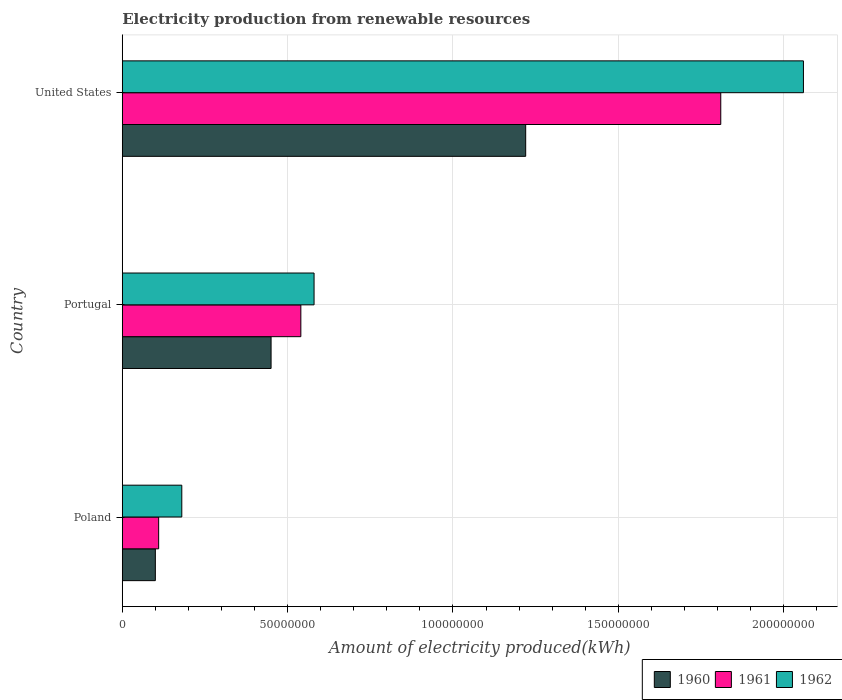How many different coloured bars are there?
Ensure brevity in your answer.  3. How many groups of bars are there?
Your response must be concise. 3. Are the number of bars on each tick of the Y-axis equal?
Offer a very short reply. Yes. How many bars are there on the 2nd tick from the bottom?
Keep it short and to the point. 3. What is the label of the 3rd group of bars from the top?
Your answer should be very brief. Poland. In how many cases, is the number of bars for a given country not equal to the number of legend labels?
Your response must be concise. 0. What is the amount of electricity produced in 1962 in Portugal?
Your answer should be very brief. 5.80e+07. Across all countries, what is the maximum amount of electricity produced in 1960?
Give a very brief answer. 1.22e+08. Across all countries, what is the minimum amount of electricity produced in 1961?
Ensure brevity in your answer.  1.10e+07. In which country was the amount of electricity produced in 1961 maximum?
Your answer should be compact. United States. In which country was the amount of electricity produced in 1961 minimum?
Your answer should be very brief. Poland. What is the total amount of electricity produced in 1962 in the graph?
Offer a terse response. 2.82e+08. What is the difference between the amount of electricity produced in 1961 in Poland and that in Portugal?
Give a very brief answer. -4.30e+07. What is the difference between the amount of electricity produced in 1962 in Poland and the amount of electricity produced in 1961 in United States?
Offer a terse response. -1.63e+08. What is the average amount of electricity produced in 1960 per country?
Your answer should be very brief. 5.90e+07. What is the difference between the amount of electricity produced in 1961 and amount of electricity produced in 1962 in United States?
Your answer should be compact. -2.50e+07. What is the ratio of the amount of electricity produced in 1960 in Poland to that in United States?
Provide a short and direct response. 0.08. Is the difference between the amount of electricity produced in 1961 in Portugal and United States greater than the difference between the amount of electricity produced in 1962 in Portugal and United States?
Keep it short and to the point. Yes. What is the difference between the highest and the second highest amount of electricity produced in 1962?
Offer a very short reply. 1.48e+08. What is the difference between the highest and the lowest amount of electricity produced in 1960?
Your answer should be compact. 1.12e+08. Is the sum of the amount of electricity produced in 1962 in Poland and Portugal greater than the maximum amount of electricity produced in 1961 across all countries?
Keep it short and to the point. No. What does the 3rd bar from the bottom in Poland represents?
Provide a short and direct response. 1962. How many bars are there?
Your answer should be very brief. 9. Are all the bars in the graph horizontal?
Ensure brevity in your answer.  Yes. How many countries are there in the graph?
Offer a terse response. 3. What is the difference between two consecutive major ticks on the X-axis?
Ensure brevity in your answer.  5.00e+07. Where does the legend appear in the graph?
Make the answer very short. Bottom right. What is the title of the graph?
Your answer should be compact. Electricity production from renewable resources. Does "1975" appear as one of the legend labels in the graph?
Provide a succinct answer. No. What is the label or title of the X-axis?
Your response must be concise. Amount of electricity produced(kWh). What is the Amount of electricity produced(kWh) in 1961 in Poland?
Make the answer very short. 1.10e+07. What is the Amount of electricity produced(kWh) in 1962 in Poland?
Provide a succinct answer. 1.80e+07. What is the Amount of electricity produced(kWh) in 1960 in Portugal?
Your answer should be very brief. 4.50e+07. What is the Amount of electricity produced(kWh) of 1961 in Portugal?
Offer a terse response. 5.40e+07. What is the Amount of electricity produced(kWh) in 1962 in Portugal?
Make the answer very short. 5.80e+07. What is the Amount of electricity produced(kWh) of 1960 in United States?
Offer a terse response. 1.22e+08. What is the Amount of electricity produced(kWh) in 1961 in United States?
Give a very brief answer. 1.81e+08. What is the Amount of electricity produced(kWh) of 1962 in United States?
Ensure brevity in your answer.  2.06e+08. Across all countries, what is the maximum Amount of electricity produced(kWh) of 1960?
Provide a succinct answer. 1.22e+08. Across all countries, what is the maximum Amount of electricity produced(kWh) in 1961?
Offer a terse response. 1.81e+08. Across all countries, what is the maximum Amount of electricity produced(kWh) of 1962?
Your answer should be compact. 2.06e+08. Across all countries, what is the minimum Amount of electricity produced(kWh) of 1960?
Give a very brief answer. 1.00e+07. Across all countries, what is the minimum Amount of electricity produced(kWh) of 1961?
Your answer should be very brief. 1.10e+07. Across all countries, what is the minimum Amount of electricity produced(kWh) of 1962?
Your response must be concise. 1.80e+07. What is the total Amount of electricity produced(kWh) of 1960 in the graph?
Give a very brief answer. 1.77e+08. What is the total Amount of electricity produced(kWh) of 1961 in the graph?
Make the answer very short. 2.46e+08. What is the total Amount of electricity produced(kWh) in 1962 in the graph?
Your answer should be compact. 2.82e+08. What is the difference between the Amount of electricity produced(kWh) of 1960 in Poland and that in Portugal?
Provide a succinct answer. -3.50e+07. What is the difference between the Amount of electricity produced(kWh) in 1961 in Poland and that in Portugal?
Ensure brevity in your answer.  -4.30e+07. What is the difference between the Amount of electricity produced(kWh) of 1962 in Poland and that in Portugal?
Your answer should be very brief. -4.00e+07. What is the difference between the Amount of electricity produced(kWh) of 1960 in Poland and that in United States?
Provide a short and direct response. -1.12e+08. What is the difference between the Amount of electricity produced(kWh) of 1961 in Poland and that in United States?
Your answer should be very brief. -1.70e+08. What is the difference between the Amount of electricity produced(kWh) in 1962 in Poland and that in United States?
Your answer should be very brief. -1.88e+08. What is the difference between the Amount of electricity produced(kWh) in 1960 in Portugal and that in United States?
Keep it short and to the point. -7.70e+07. What is the difference between the Amount of electricity produced(kWh) in 1961 in Portugal and that in United States?
Provide a short and direct response. -1.27e+08. What is the difference between the Amount of electricity produced(kWh) of 1962 in Portugal and that in United States?
Provide a short and direct response. -1.48e+08. What is the difference between the Amount of electricity produced(kWh) of 1960 in Poland and the Amount of electricity produced(kWh) of 1961 in Portugal?
Offer a terse response. -4.40e+07. What is the difference between the Amount of electricity produced(kWh) in 1960 in Poland and the Amount of electricity produced(kWh) in 1962 in Portugal?
Your answer should be very brief. -4.80e+07. What is the difference between the Amount of electricity produced(kWh) in 1961 in Poland and the Amount of electricity produced(kWh) in 1962 in Portugal?
Give a very brief answer. -4.70e+07. What is the difference between the Amount of electricity produced(kWh) in 1960 in Poland and the Amount of electricity produced(kWh) in 1961 in United States?
Provide a short and direct response. -1.71e+08. What is the difference between the Amount of electricity produced(kWh) of 1960 in Poland and the Amount of electricity produced(kWh) of 1962 in United States?
Make the answer very short. -1.96e+08. What is the difference between the Amount of electricity produced(kWh) of 1961 in Poland and the Amount of electricity produced(kWh) of 1962 in United States?
Your response must be concise. -1.95e+08. What is the difference between the Amount of electricity produced(kWh) in 1960 in Portugal and the Amount of electricity produced(kWh) in 1961 in United States?
Provide a succinct answer. -1.36e+08. What is the difference between the Amount of electricity produced(kWh) in 1960 in Portugal and the Amount of electricity produced(kWh) in 1962 in United States?
Your answer should be very brief. -1.61e+08. What is the difference between the Amount of electricity produced(kWh) in 1961 in Portugal and the Amount of electricity produced(kWh) in 1962 in United States?
Offer a very short reply. -1.52e+08. What is the average Amount of electricity produced(kWh) of 1960 per country?
Provide a succinct answer. 5.90e+07. What is the average Amount of electricity produced(kWh) of 1961 per country?
Ensure brevity in your answer.  8.20e+07. What is the average Amount of electricity produced(kWh) in 1962 per country?
Your answer should be very brief. 9.40e+07. What is the difference between the Amount of electricity produced(kWh) in 1960 and Amount of electricity produced(kWh) in 1961 in Poland?
Make the answer very short. -1.00e+06. What is the difference between the Amount of electricity produced(kWh) in 1960 and Amount of electricity produced(kWh) in 1962 in Poland?
Ensure brevity in your answer.  -8.00e+06. What is the difference between the Amount of electricity produced(kWh) in 1961 and Amount of electricity produced(kWh) in 1962 in Poland?
Keep it short and to the point. -7.00e+06. What is the difference between the Amount of electricity produced(kWh) of 1960 and Amount of electricity produced(kWh) of 1961 in Portugal?
Give a very brief answer. -9.00e+06. What is the difference between the Amount of electricity produced(kWh) of 1960 and Amount of electricity produced(kWh) of 1962 in Portugal?
Give a very brief answer. -1.30e+07. What is the difference between the Amount of electricity produced(kWh) of 1961 and Amount of electricity produced(kWh) of 1962 in Portugal?
Give a very brief answer. -4.00e+06. What is the difference between the Amount of electricity produced(kWh) in 1960 and Amount of electricity produced(kWh) in 1961 in United States?
Make the answer very short. -5.90e+07. What is the difference between the Amount of electricity produced(kWh) of 1960 and Amount of electricity produced(kWh) of 1962 in United States?
Your answer should be very brief. -8.40e+07. What is the difference between the Amount of electricity produced(kWh) in 1961 and Amount of electricity produced(kWh) in 1962 in United States?
Ensure brevity in your answer.  -2.50e+07. What is the ratio of the Amount of electricity produced(kWh) of 1960 in Poland to that in Portugal?
Ensure brevity in your answer.  0.22. What is the ratio of the Amount of electricity produced(kWh) of 1961 in Poland to that in Portugal?
Offer a very short reply. 0.2. What is the ratio of the Amount of electricity produced(kWh) of 1962 in Poland to that in Portugal?
Ensure brevity in your answer.  0.31. What is the ratio of the Amount of electricity produced(kWh) of 1960 in Poland to that in United States?
Provide a short and direct response. 0.08. What is the ratio of the Amount of electricity produced(kWh) in 1961 in Poland to that in United States?
Provide a short and direct response. 0.06. What is the ratio of the Amount of electricity produced(kWh) of 1962 in Poland to that in United States?
Provide a succinct answer. 0.09. What is the ratio of the Amount of electricity produced(kWh) in 1960 in Portugal to that in United States?
Provide a short and direct response. 0.37. What is the ratio of the Amount of electricity produced(kWh) of 1961 in Portugal to that in United States?
Ensure brevity in your answer.  0.3. What is the ratio of the Amount of electricity produced(kWh) of 1962 in Portugal to that in United States?
Your response must be concise. 0.28. What is the difference between the highest and the second highest Amount of electricity produced(kWh) in 1960?
Give a very brief answer. 7.70e+07. What is the difference between the highest and the second highest Amount of electricity produced(kWh) in 1961?
Offer a very short reply. 1.27e+08. What is the difference between the highest and the second highest Amount of electricity produced(kWh) of 1962?
Offer a very short reply. 1.48e+08. What is the difference between the highest and the lowest Amount of electricity produced(kWh) in 1960?
Give a very brief answer. 1.12e+08. What is the difference between the highest and the lowest Amount of electricity produced(kWh) in 1961?
Provide a short and direct response. 1.70e+08. What is the difference between the highest and the lowest Amount of electricity produced(kWh) in 1962?
Make the answer very short. 1.88e+08. 